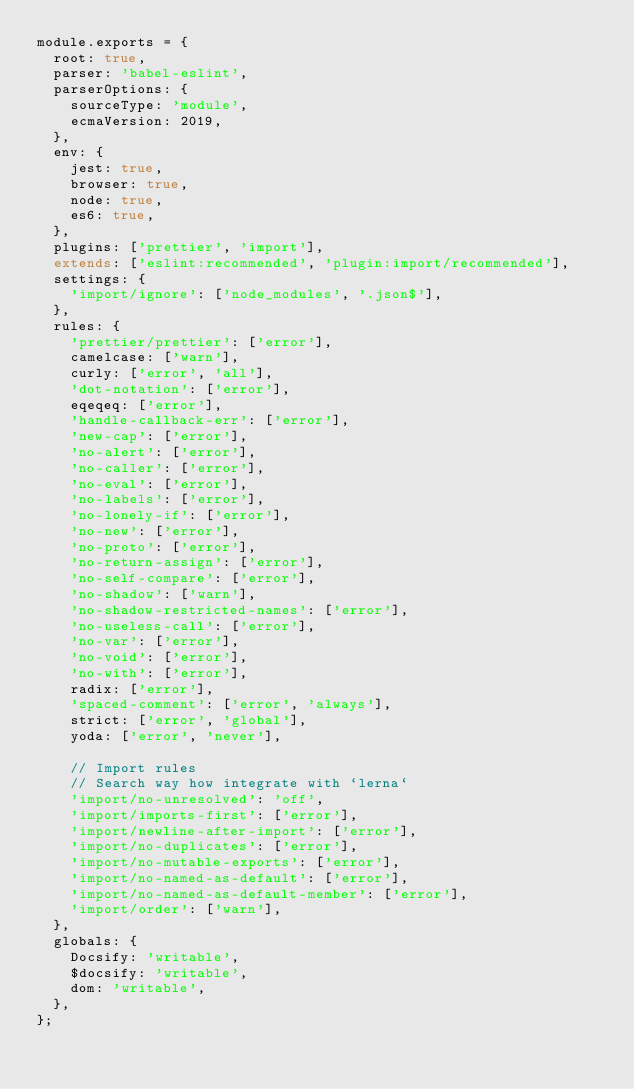<code> <loc_0><loc_0><loc_500><loc_500><_JavaScript_>module.exports = {
  root: true,
  parser: 'babel-eslint',
  parserOptions: {
    sourceType: 'module',
    ecmaVersion: 2019,
  },
  env: {
    jest: true,
    browser: true,
    node: true,
    es6: true,
  },
  plugins: ['prettier', 'import'],
  extends: ['eslint:recommended', 'plugin:import/recommended'],
  settings: {
    'import/ignore': ['node_modules', '.json$'],
  },
  rules: {
    'prettier/prettier': ['error'],
    camelcase: ['warn'],
    curly: ['error', 'all'],
    'dot-notation': ['error'],
    eqeqeq: ['error'],
    'handle-callback-err': ['error'],
    'new-cap': ['error'],
    'no-alert': ['error'],
    'no-caller': ['error'],
    'no-eval': ['error'],
    'no-labels': ['error'],
    'no-lonely-if': ['error'],
    'no-new': ['error'],
    'no-proto': ['error'],
    'no-return-assign': ['error'],
    'no-self-compare': ['error'],
    'no-shadow': ['warn'],
    'no-shadow-restricted-names': ['error'],
    'no-useless-call': ['error'],
    'no-var': ['error'],
    'no-void': ['error'],
    'no-with': ['error'],
    radix: ['error'],
    'spaced-comment': ['error', 'always'],
    strict: ['error', 'global'],
    yoda: ['error', 'never'],

    // Import rules
    // Search way how integrate with `lerna`
    'import/no-unresolved': 'off',
    'import/imports-first': ['error'],
    'import/newline-after-import': ['error'],
    'import/no-duplicates': ['error'],
    'import/no-mutable-exports': ['error'],
    'import/no-named-as-default': ['error'],
    'import/no-named-as-default-member': ['error'],
    'import/order': ['warn'],
  },
  globals: {
    Docsify: 'writable',
    $docsify: 'writable',
    dom: 'writable',
  },
};
</code> 